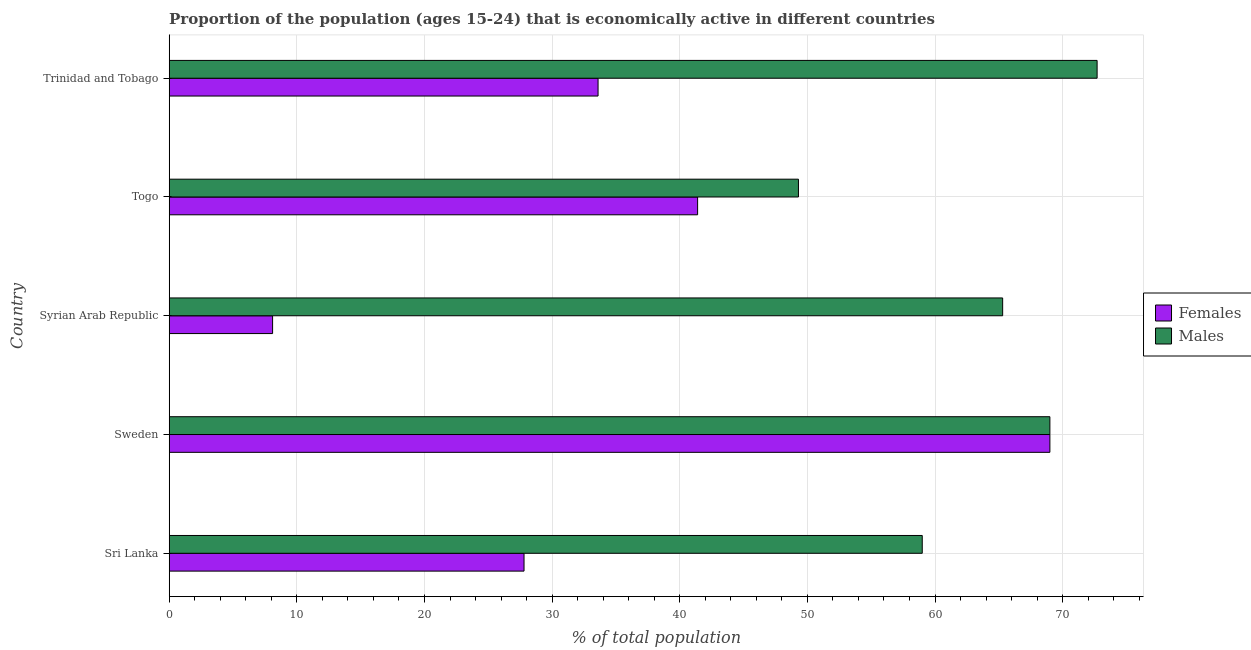How many different coloured bars are there?
Offer a very short reply. 2. How many groups of bars are there?
Provide a short and direct response. 5. Are the number of bars on each tick of the Y-axis equal?
Offer a terse response. Yes. How many bars are there on the 5th tick from the bottom?
Keep it short and to the point. 2. What is the label of the 2nd group of bars from the top?
Ensure brevity in your answer.  Togo. What is the percentage of economically active male population in Syrian Arab Republic?
Provide a short and direct response. 65.3. Across all countries, what is the minimum percentage of economically active female population?
Provide a succinct answer. 8.1. In which country was the percentage of economically active male population maximum?
Your answer should be compact. Trinidad and Tobago. In which country was the percentage of economically active male population minimum?
Offer a terse response. Togo. What is the total percentage of economically active female population in the graph?
Your answer should be very brief. 179.9. What is the difference between the percentage of economically active male population in Sri Lanka and the percentage of economically active female population in Togo?
Offer a very short reply. 17.6. What is the average percentage of economically active female population per country?
Keep it short and to the point. 35.98. What is the difference between the percentage of economically active male population and percentage of economically active female population in Trinidad and Tobago?
Your answer should be compact. 39.1. In how many countries, is the percentage of economically active male population greater than 36 %?
Ensure brevity in your answer.  5. What is the ratio of the percentage of economically active male population in Sri Lanka to that in Togo?
Your response must be concise. 1.2. Is the percentage of economically active female population in Sri Lanka less than that in Togo?
Provide a short and direct response. Yes. Is the difference between the percentage of economically active male population in Sri Lanka and Trinidad and Tobago greater than the difference between the percentage of economically active female population in Sri Lanka and Trinidad and Tobago?
Provide a short and direct response. No. What is the difference between the highest and the second highest percentage of economically active female population?
Make the answer very short. 27.6. What is the difference between the highest and the lowest percentage of economically active male population?
Offer a terse response. 23.4. What does the 2nd bar from the top in Syrian Arab Republic represents?
Offer a terse response. Females. What does the 1st bar from the bottom in Togo represents?
Make the answer very short. Females. How many bars are there?
Make the answer very short. 10. Does the graph contain grids?
Keep it short and to the point. Yes. Where does the legend appear in the graph?
Provide a short and direct response. Center right. What is the title of the graph?
Offer a very short reply. Proportion of the population (ages 15-24) that is economically active in different countries. Does "Rural" appear as one of the legend labels in the graph?
Offer a very short reply. No. What is the label or title of the X-axis?
Ensure brevity in your answer.  % of total population. What is the % of total population in Females in Sri Lanka?
Keep it short and to the point. 27.8. What is the % of total population of Males in Sri Lanka?
Your answer should be very brief. 59. What is the % of total population in Females in Sweden?
Offer a very short reply. 69. What is the % of total population in Males in Sweden?
Keep it short and to the point. 69. What is the % of total population of Females in Syrian Arab Republic?
Offer a very short reply. 8.1. What is the % of total population in Males in Syrian Arab Republic?
Give a very brief answer. 65.3. What is the % of total population of Females in Togo?
Your answer should be very brief. 41.4. What is the % of total population in Males in Togo?
Your response must be concise. 49.3. What is the % of total population of Females in Trinidad and Tobago?
Make the answer very short. 33.6. What is the % of total population of Males in Trinidad and Tobago?
Provide a short and direct response. 72.7. Across all countries, what is the maximum % of total population of Males?
Give a very brief answer. 72.7. Across all countries, what is the minimum % of total population in Females?
Offer a very short reply. 8.1. Across all countries, what is the minimum % of total population in Males?
Provide a short and direct response. 49.3. What is the total % of total population in Females in the graph?
Ensure brevity in your answer.  179.9. What is the total % of total population of Males in the graph?
Ensure brevity in your answer.  315.3. What is the difference between the % of total population in Females in Sri Lanka and that in Sweden?
Offer a very short reply. -41.2. What is the difference between the % of total population in Males in Sri Lanka and that in Sweden?
Ensure brevity in your answer.  -10. What is the difference between the % of total population of Females in Sri Lanka and that in Syrian Arab Republic?
Offer a very short reply. 19.7. What is the difference between the % of total population of Males in Sri Lanka and that in Togo?
Your answer should be compact. 9.7. What is the difference between the % of total population of Males in Sri Lanka and that in Trinidad and Tobago?
Provide a short and direct response. -13.7. What is the difference between the % of total population in Females in Sweden and that in Syrian Arab Republic?
Ensure brevity in your answer.  60.9. What is the difference between the % of total population of Females in Sweden and that in Togo?
Keep it short and to the point. 27.6. What is the difference between the % of total population of Females in Sweden and that in Trinidad and Tobago?
Provide a succinct answer. 35.4. What is the difference between the % of total population in Males in Sweden and that in Trinidad and Tobago?
Keep it short and to the point. -3.7. What is the difference between the % of total population of Females in Syrian Arab Republic and that in Togo?
Your response must be concise. -33.3. What is the difference between the % of total population in Females in Syrian Arab Republic and that in Trinidad and Tobago?
Make the answer very short. -25.5. What is the difference between the % of total population of Females in Togo and that in Trinidad and Tobago?
Keep it short and to the point. 7.8. What is the difference between the % of total population of Males in Togo and that in Trinidad and Tobago?
Make the answer very short. -23.4. What is the difference between the % of total population of Females in Sri Lanka and the % of total population of Males in Sweden?
Make the answer very short. -41.2. What is the difference between the % of total population in Females in Sri Lanka and the % of total population in Males in Syrian Arab Republic?
Give a very brief answer. -37.5. What is the difference between the % of total population in Females in Sri Lanka and the % of total population in Males in Togo?
Your answer should be very brief. -21.5. What is the difference between the % of total population of Females in Sri Lanka and the % of total population of Males in Trinidad and Tobago?
Offer a very short reply. -44.9. What is the difference between the % of total population in Females in Sweden and the % of total population in Males in Trinidad and Tobago?
Your answer should be compact. -3.7. What is the difference between the % of total population of Females in Syrian Arab Republic and the % of total population of Males in Togo?
Give a very brief answer. -41.2. What is the difference between the % of total population of Females in Syrian Arab Republic and the % of total population of Males in Trinidad and Tobago?
Make the answer very short. -64.6. What is the difference between the % of total population of Females in Togo and the % of total population of Males in Trinidad and Tobago?
Keep it short and to the point. -31.3. What is the average % of total population in Females per country?
Keep it short and to the point. 35.98. What is the average % of total population of Males per country?
Offer a terse response. 63.06. What is the difference between the % of total population of Females and % of total population of Males in Sri Lanka?
Provide a succinct answer. -31.2. What is the difference between the % of total population in Females and % of total population in Males in Sweden?
Keep it short and to the point. 0. What is the difference between the % of total population of Females and % of total population of Males in Syrian Arab Republic?
Offer a very short reply. -57.2. What is the difference between the % of total population of Females and % of total population of Males in Togo?
Your answer should be compact. -7.9. What is the difference between the % of total population of Females and % of total population of Males in Trinidad and Tobago?
Your response must be concise. -39.1. What is the ratio of the % of total population of Females in Sri Lanka to that in Sweden?
Your answer should be very brief. 0.4. What is the ratio of the % of total population in Males in Sri Lanka to that in Sweden?
Keep it short and to the point. 0.86. What is the ratio of the % of total population in Females in Sri Lanka to that in Syrian Arab Republic?
Provide a succinct answer. 3.43. What is the ratio of the % of total population of Males in Sri Lanka to that in Syrian Arab Republic?
Offer a very short reply. 0.9. What is the ratio of the % of total population in Females in Sri Lanka to that in Togo?
Provide a short and direct response. 0.67. What is the ratio of the % of total population of Males in Sri Lanka to that in Togo?
Give a very brief answer. 1.2. What is the ratio of the % of total population of Females in Sri Lanka to that in Trinidad and Tobago?
Offer a terse response. 0.83. What is the ratio of the % of total population in Males in Sri Lanka to that in Trinidad and Tobago?
Offer a very short reply. 0.81. What is the ratio of the % of total population in Females in Sweden to that in Syrian Arab Republic?
Provide a succinct answer. 8.52. What is the ratio of the % of total population in Males in Sweden to that in Syrian Arab Republic?
Ensure brevity in your answer.  1.06. What is the ratio of the % of total population of Females in Sweden to that in Togo?
Offer a very short reply. 1.67. What is the ratio of the % of total population in Males in Sweden to that in Togo?
Your answer should be very brief. 1.4. What is the ratio of the % of total population of Females in Sweden to that in Trinidad and Tobago?
Provide a short and direct response. 2.05. What is the ratio of the % of total population in Males in Sweden to that in Trinidad and Tobago?
Keep it short and to the point. 0.95. What is the ratio of the % of total population of Females in Syrian Arab Republic to that in Togo?
Your answer should be very brief. 0.2. What is the ratio of the % of total population in Males in Syrian Arab Republic to that in Togo?
Offer a terse response. 1.32. What is the ratio of the % of total population in Females in Syrian Arab Republic to that in Trinidad and Tobago?
Your response must be concise. 0.24. What is the ratio of the % of total population of Males in Syrian Arab Republic to that in Trinidad and Tobago?
Make the answer very short. 0.9. What is the ratio of the % of total population of Females in Togo to that in Trinidad and Tobago?
Your answer should be very brief. 1.23. What is the ratio of the % of total population of Males in Togo to that in Trinidad and Tobago?
Your answer should be compact. 0.68. What is the difference between the highest and the second highest % of total population of Females?
Offer a very short reply. 27.6. What is the difference between the highest and the second highest % of total population of Males?
Make the answer very short. 3.7. What is the difference between the highest and the lowest % of total population of Females?
Offer a terse response. 60.9. What is the difference between the highest and the lowest % of total population of Males?
Offer a terse response. 23.4. 